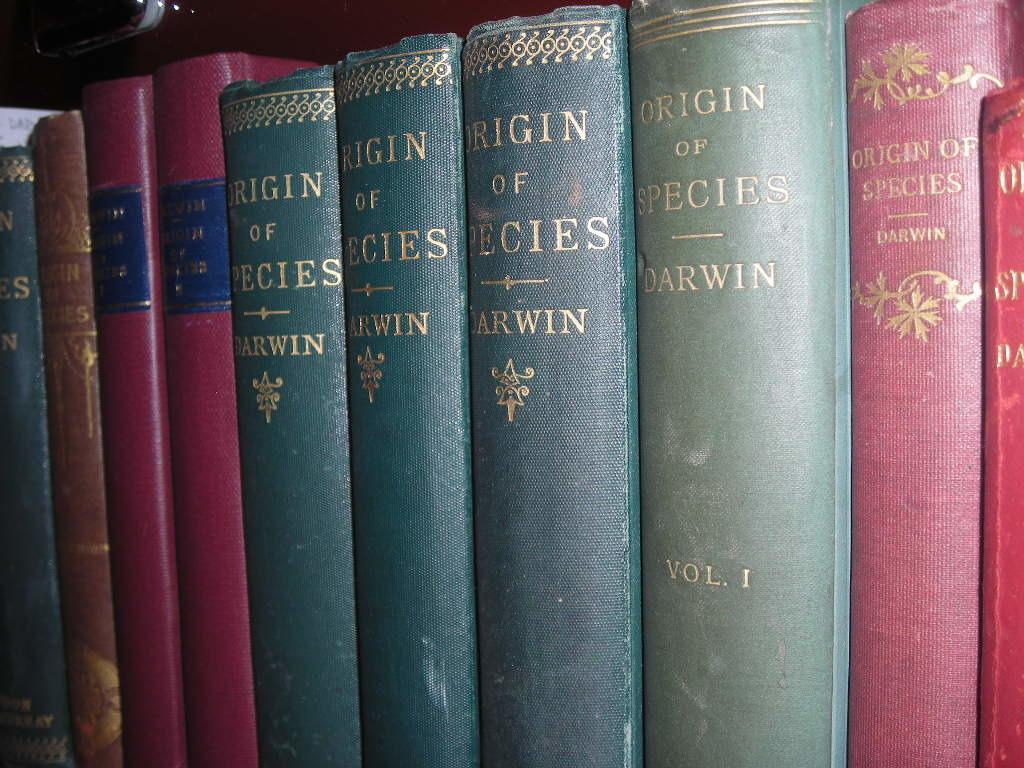<image>
Create a compact narrative representing the image presented. the origin of species that was written by Darwin 